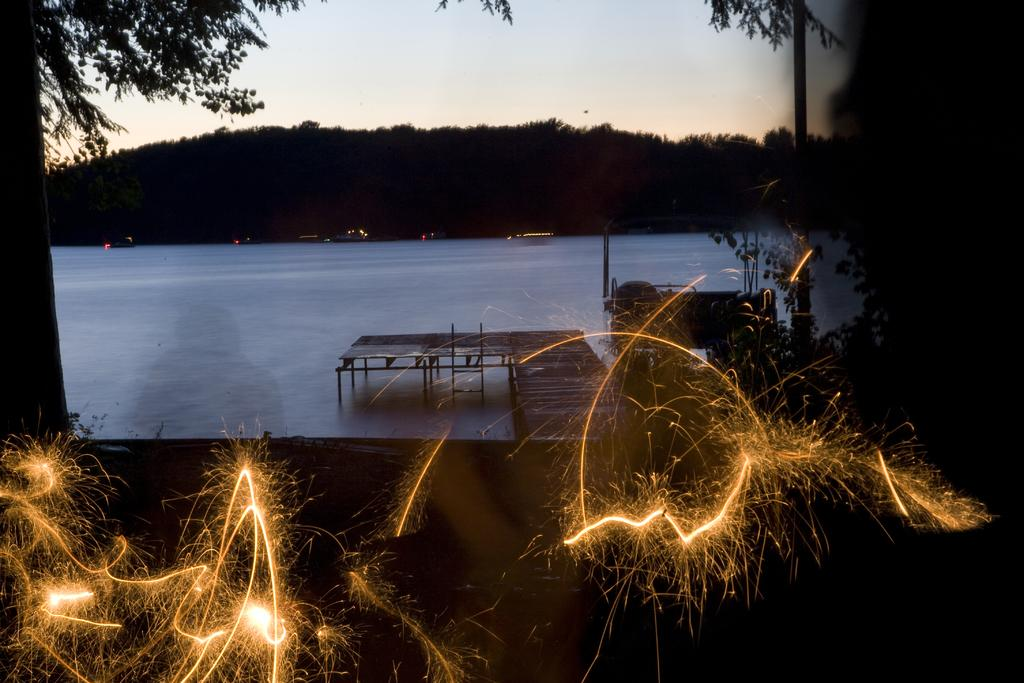What can be seen in the image that sparkles? There are sparkles in the image. What is the main body of water visible in the image? There is water visible in the image. What structure can be seen crossing the water in the image? There is a bridge in the image. What type of vegetation is present in the image? There are trees in the image. What can be seen in the background of the image? In the background, there are trees, lights, and sky visible. How many fingers does the lamp have in the image? There is no lamp present in the image, so it is not possible to determine the number of fingers it might have. 